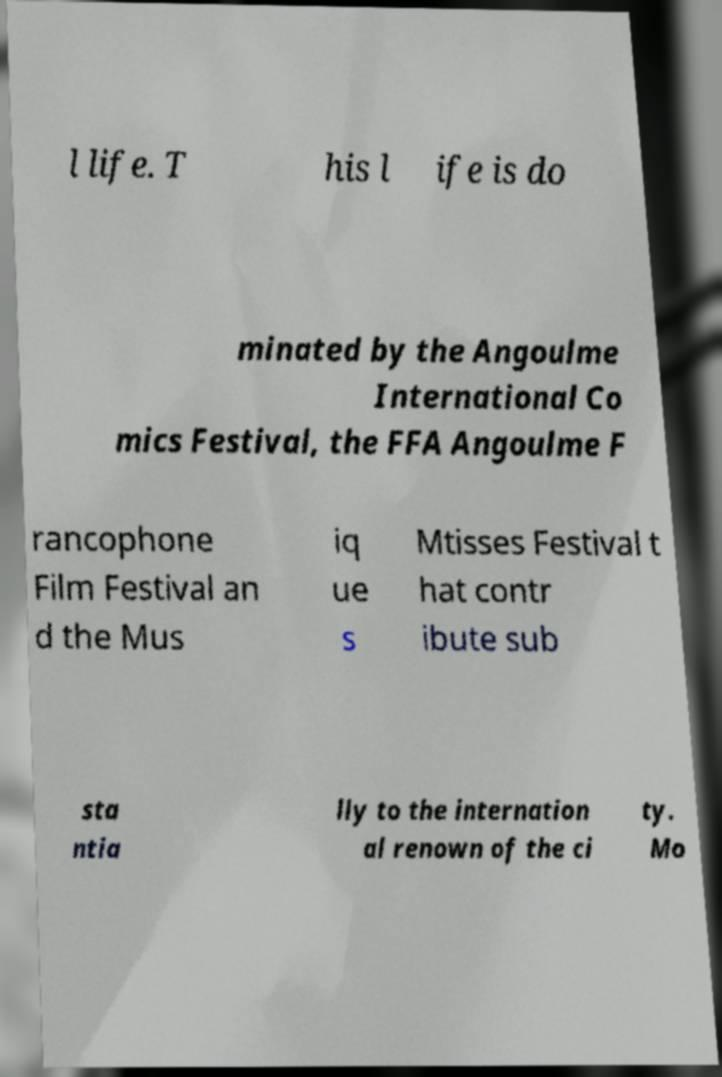Could you assist in decoding the text presented in this image and type it out clearly? l life. T his l ife is do minated by the Angoulme International Co mics Festival, the FFA Angoulme F rancophone Film Festival an d the Mus iq ue s Mtisses Festival t hat contr ibute sub sta ntia lly to the internation al renown of the ci ty. Mo 